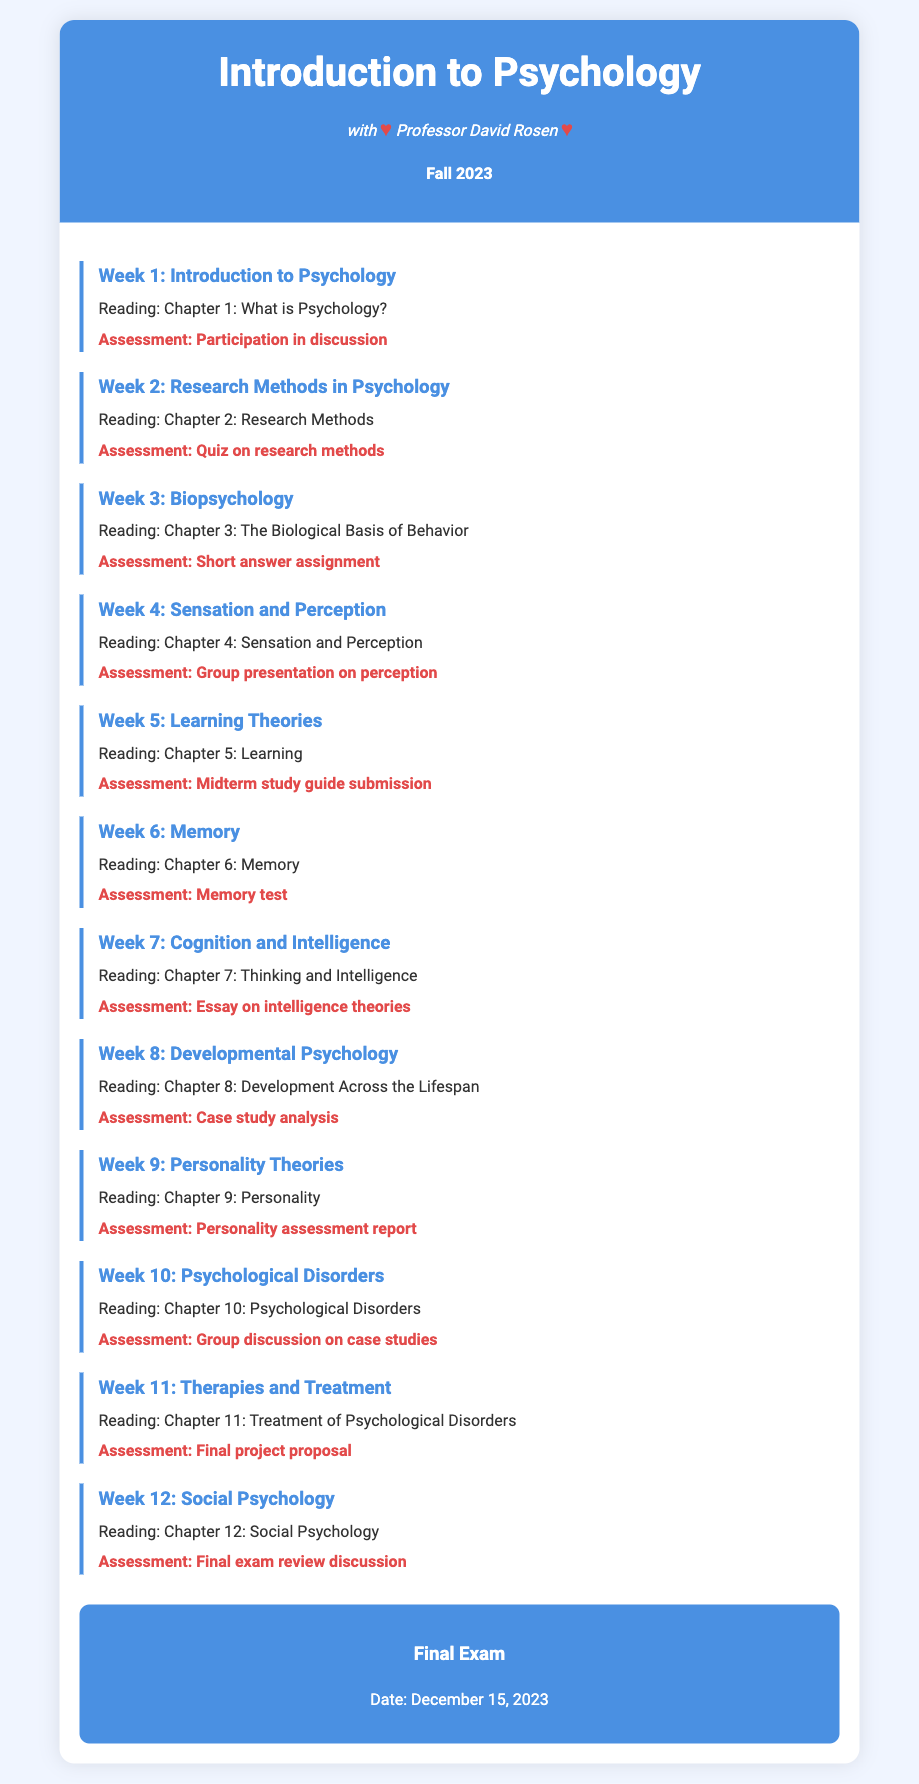What is the title of the course? The title is specified in the header of the document.
Answer: Introduction to Psychology Who is the instructor of the course? The instructor's name is mentioned directly under the course title.
Answer: Professor David Rosen What is the semester for this course? The semester is noted below the instructor's name in the header section.
Answer: Fall 2023 In which week is the topic "Personality Theories" covered? The week in which this topic is discussed is labeled clearly in the week section of the syllabus.
Answer: Week 9 What reading is assigned for Week 6? The specific reading for Week 6 is listed under its corresponding week header in the document.
Answer: Chapter 6: Memory What type of assessment is given for "Developmental Psychology"? The assessment type for this week is indicated under the corresponding week section of the syllabus.
Answer: Case study analysis When is the final exam scheduled? The date of the final exam is prominently displayed in the final assessment section of the document.
Answer: December 15, 2023 What is the assessment method for Week 4's topic? The method of assessment for Week 4 is specified in the agenda under that week.
Answer: Group presentation on perception How many weeks are included in the syllabus? The number of weeks can be counted based on the week sections detailed in the document.
Answer: 12 